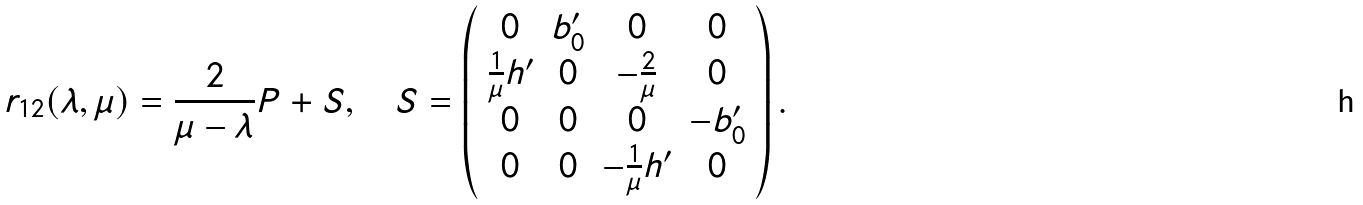Convert formula to latex. <formula><loc_0><loc_0><loc_500><loc_500>r _ { 1 2 } ( \lambda , \mu ) = \frac { 2 } { \mu - \lambda } P + S , \quad S = \left ( \begin{array} { c c c c } 0 & b ^ { \prime } _ { 0 } & 0 & 0 \\ \frac { 1 } { \mu } h ^ { \prime } & 0 & - \frac { 2 } { \mu } & 0 \\ 0 & 0 & 0 & - b ^ { \prime } _ { 0 } \\ 0 & 0 & - \frac { 1 } { \mu } h ^ { \prime } & 0 \end{array} \right ) .</formula> 